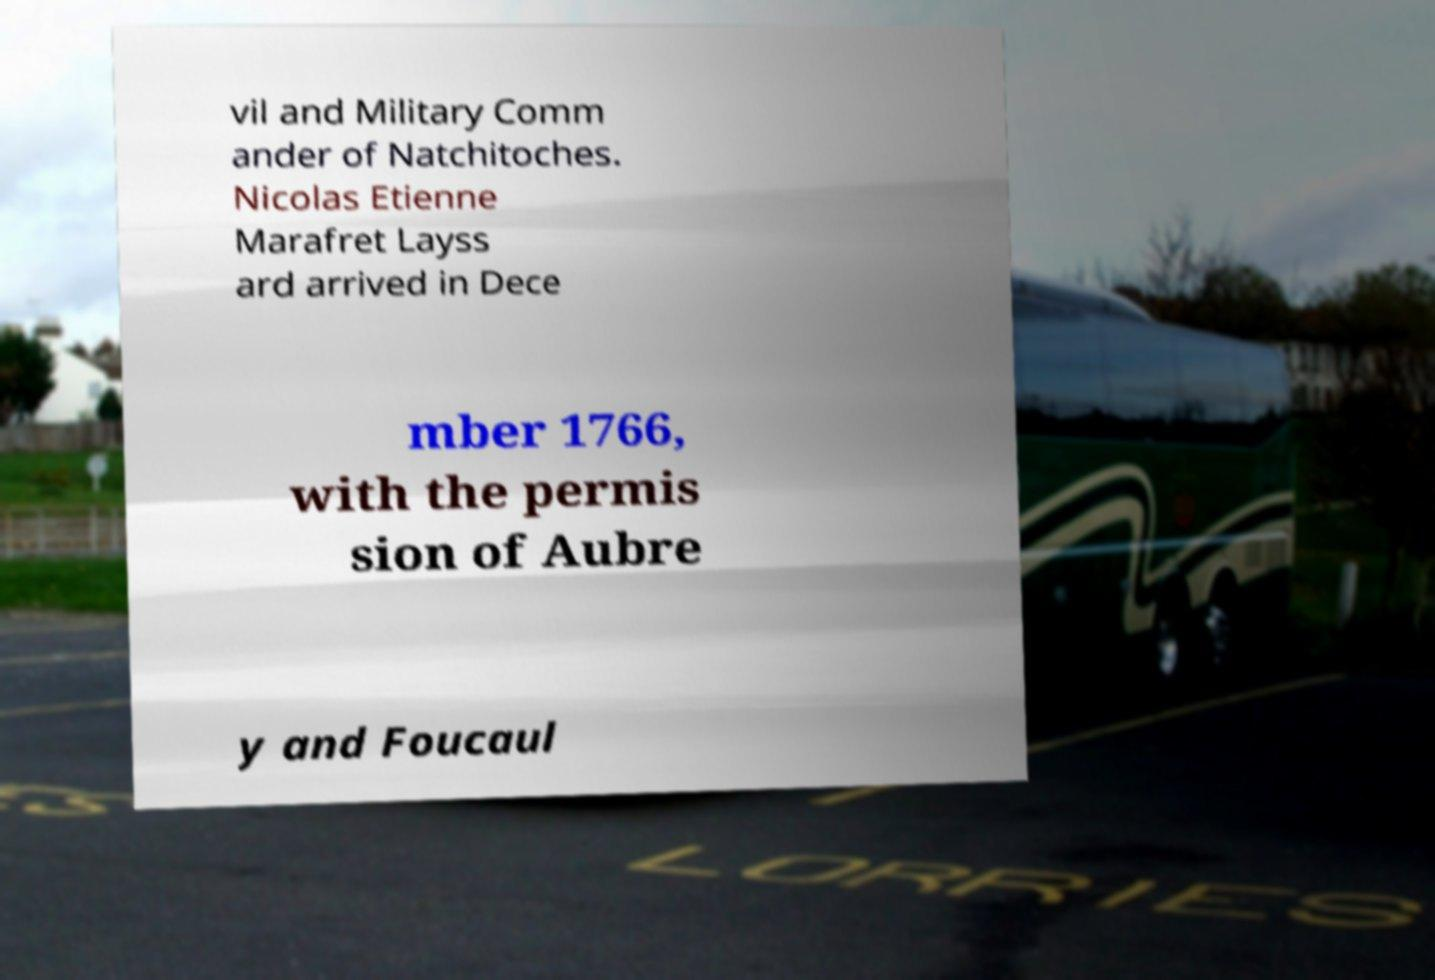Could you assist in decoding the text presented in this image and type it out clearly? vil and Military Comm ander of Natchitoches. Nicolas Etienne Marafret Layss ard arrived in Dece mber 1766, with the permis sion of Aubre y and Foucaul 